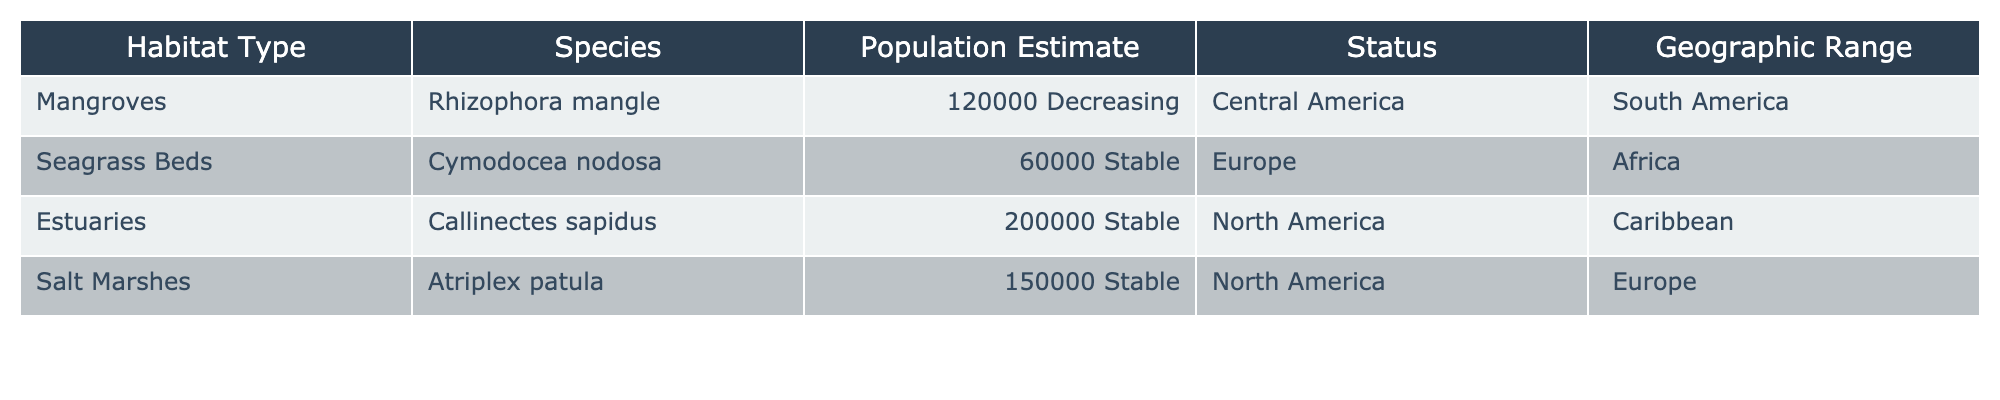What is the population estimate for Rhizophora mangle? The table lists the population estimate for Rhizophora mangle in the row corresponding to Mangroves, which shows 120000 as the population estimate.
Answer: 120000 Which species has the largest population estimate? By comparing the population estimates of all species in the table, the highest value is 200000 for Callinectes sapidus, which belongs to Estuaries.
Answer: Callinectes sapidus Are there any species with a decreasing population status? The table shows the population status for each species, and it indicates that only Rhizophora mangle has a status of "Decreasing."
Answer: Yes What is the total population estimate for species in North America? Examining the population estimates for species located in North America, we see Callinectes sapidus (200000) and Atriplex patula (150000). Adding these two values gives 350000.
Answer: 350000 Which habitat type has a stable population status and is found in both North America and Europe? The table presents Atriplex patula, which is located in Salt Marshes, and has a stable population status. It is listed under both North America and Europe.
Answer: Atriplex patula Is the population of Cymodocea nodosa stable or decreasing? Looking at the status in the row for Cymodocea nodosa, it clearly states that the status is "Stable."
Answer: Stable What is the average population estimate of species found in North America? The species found in North America are Callinectes sapidus (200000) and Atriplex patula (150000). Adding these gives 350000, divided by 2 gives an average of 175000.
Answer: 175000 Which species has the largest geographic range? Reviewing the geographic range in the table, Callinectes sapidus has the geographic range: "North America, Caribbean," which is larger compared to others listed.
Answer: Callinectes sapidus How many species are listed in Europe? By checking the geographic range, Cymodocea nodosa and Atriplex patula are the two species mentioned in Europe. Hence, there are 2 species listed in Europe.
Answer: 2 Is there any species with a population estimate of less than 100000? The population estimate for Cymodocea nodosa is 60000, which is less than 100000.
Answer: Yes 